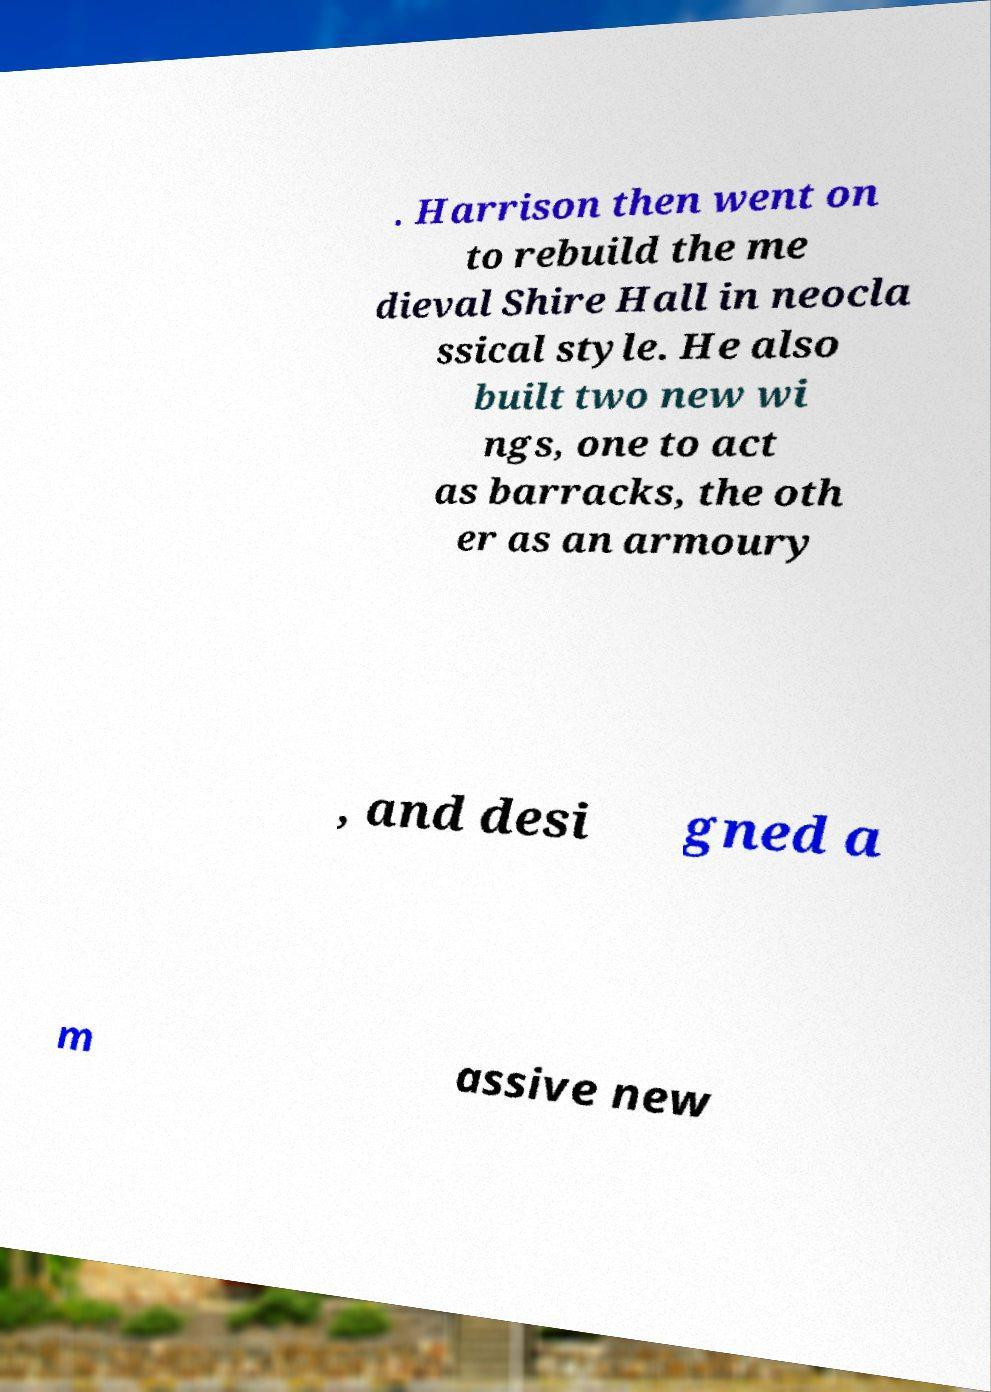I need the written content from this picture converted into text. Can you do that? . Harrison then went on to rebuild the me dieval Shire Hall in neocla ssical style. He also built two new wi ngs, one to act as barracks, the oth er as an armoury , and desi gned a m assive new 